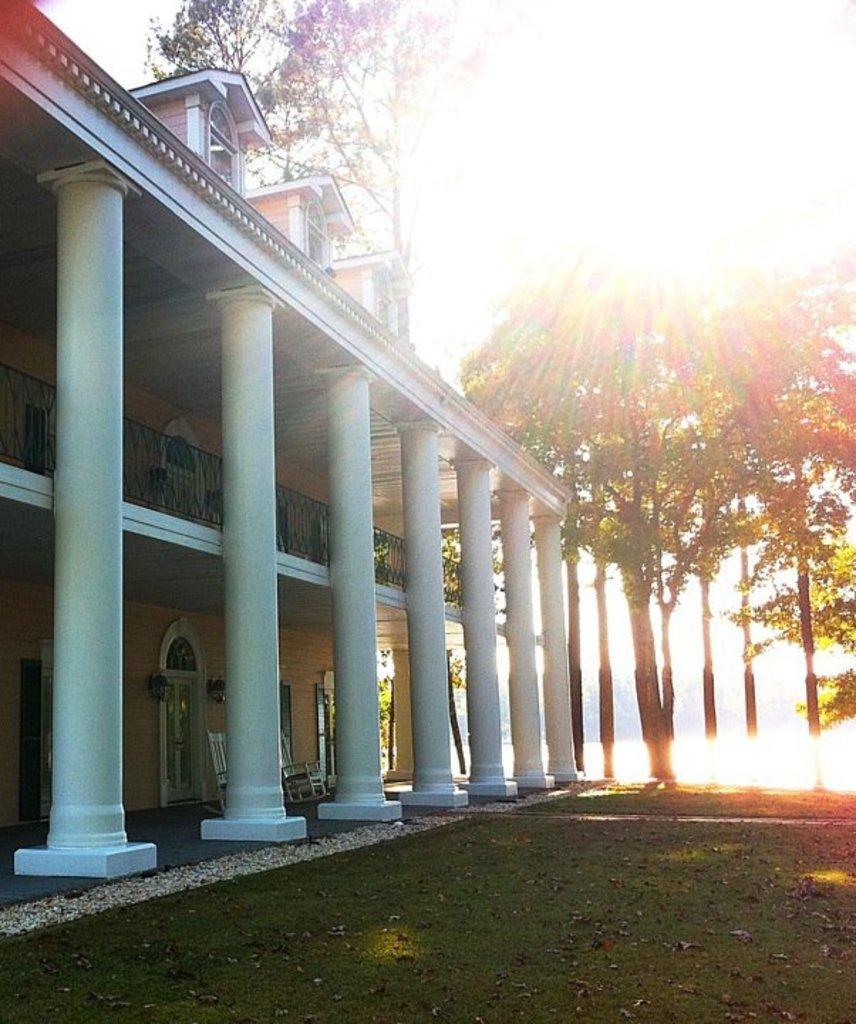Describe this image in one or two sentences. In this image, we can see a building and there are trees and there is sunlight and we can see some pillars. At the bottom, there is a ground. 